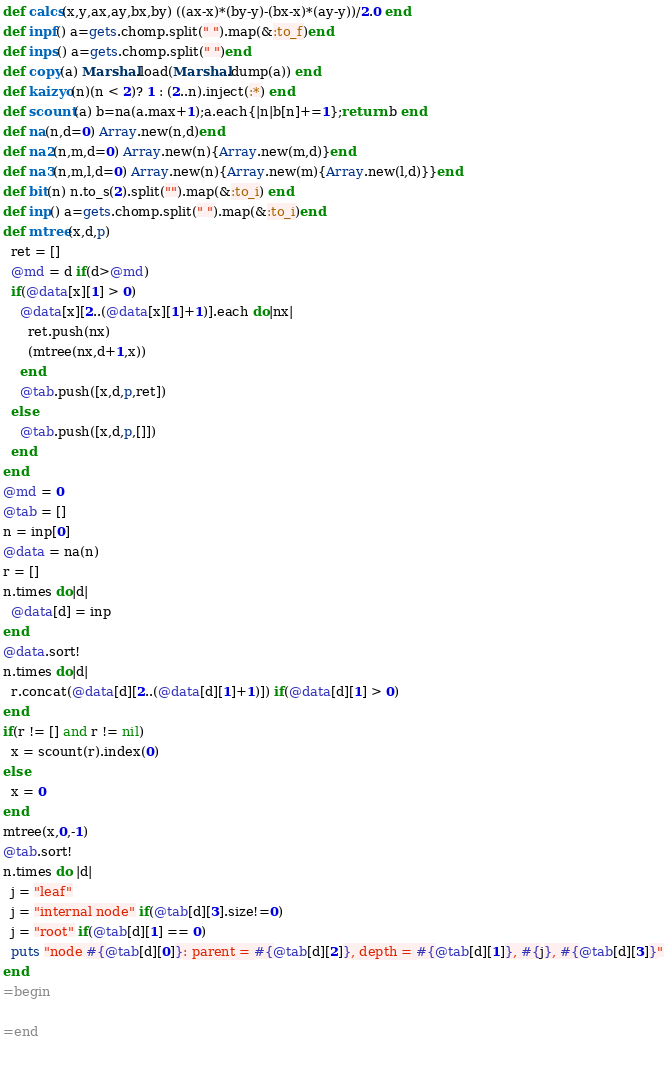<code> <loc_0><loc_0><loc_500><loc_500><_Ruby_>def calcs(x,y,ax,ay,bx,by) ((ax-x)*(by-y)-(bx-x)*(ay-y))/2.0 end
def inpf() a=gets.chomp.split(" ").map(&:to_f)end
def inps() a=gets.chomp.split(" ")end  
def copy(a) Marshal.load(Marshal.dump(a)) end
def kaizyo(n)(n < 2)? 1 : (2..n).inject(:*) end
def scount(a) b=na(a.max+1);a.each{|n|b[n]+=1};return b end
def na(n,d=0) Array.new(n,d)end
def na2(n,m,d=0) Array.new(n){Array.new(m,d)}end
def na3(n,m,l,d=0) Array.new(n){Array.new(m){Array.new(l,d)}}end
def bit(n) n.to_s(2).split("").map(&:to_i) end
def inp() a=gets.chomp.split(" ").map(&:to_i)end 
def mtree(x,d,p)
  ret = []
  @md = d if(d>@md)
  if(@data[x][1] > 0)
    @data[x][2..(@data[x][1]+1)].each do|nx|
      ret.push(nx)
      (mtree(nx,d+1,x))
    end
    @tab.push([x,d,p,ret])
  else
    @tab.push([x,d,p,[]])
  end
end
@md = 0
@tab = []
n = inp[0]
@data = na(n)
r = []
n.times do|d|
  @data[d] = inp
end
@data.sort!
n.times do|d|
  r.concat(@data[d][2..(@data[d][1]+1)]) if(@data[d][1] > 0)
end
if(r != [] and r != nil)
  x = scount(r).index(0)
else
  x = 0
end 
mtree(x,0,-1)
@tab.sort!
n.times do |d|
  j = "leaf"
  j = "internal node" if(@tab[d][3].size!=0)
  j = "root" if(@tab[d][1] == 0)
  puts "node #{@tab[d][0]}: parent = #{@tab[d][2]}, depth = #{@tab[d][1]}, #{j}, #{@tab[d][3]}"
end
=begin

=end

  </code> 